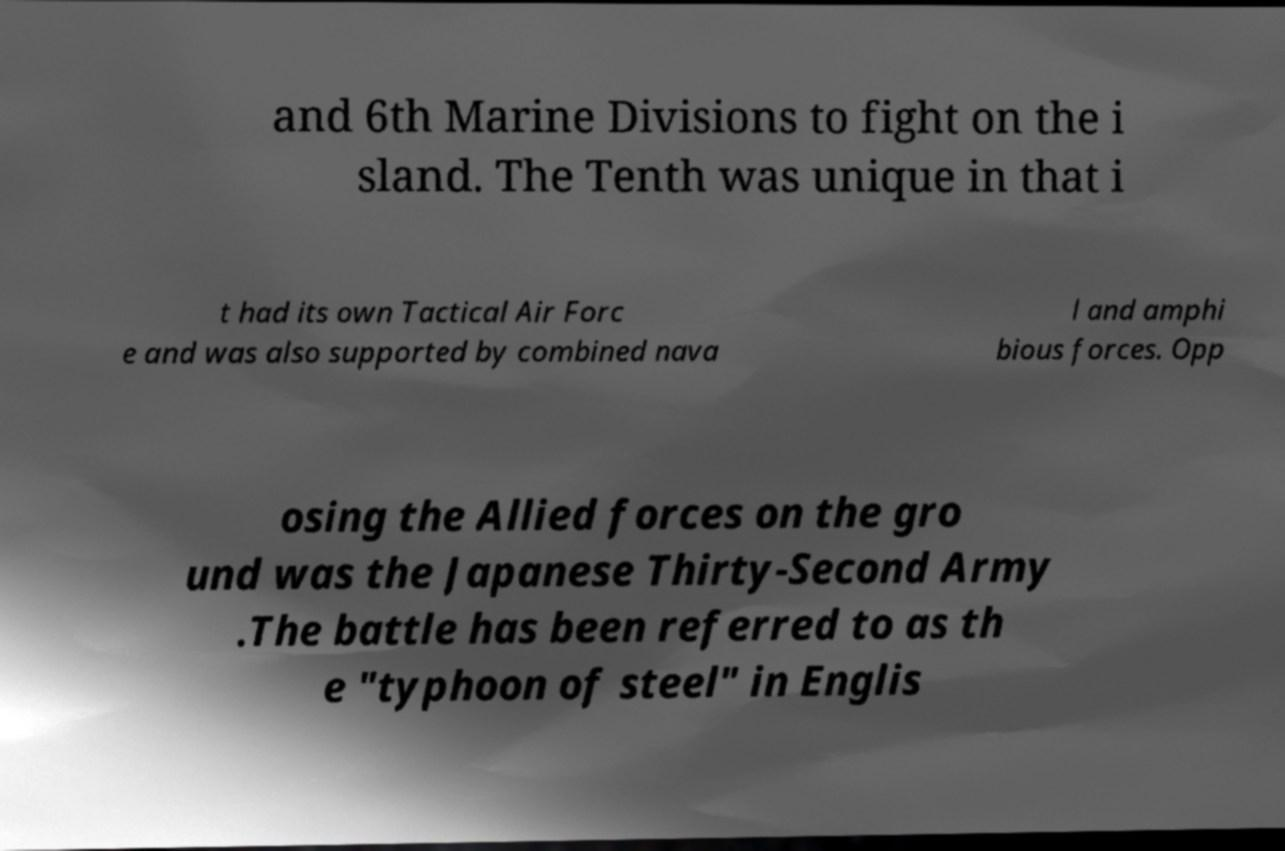Can you read and provide the text displayed in the image?This photo seems to have some interesting text. Can you extract and type it out for me? and 6th Marine Divisions to fight on the i sland. The Tenth was unique in that i t had its own Tactical Air Forc e and was also supported by combined nava l and amphi bious forces. Opp osing the Allied forces on the gro und was the Japanese Thirty-Second Army .The battle has been referred to as th e "typhoon of steel" in Englis 